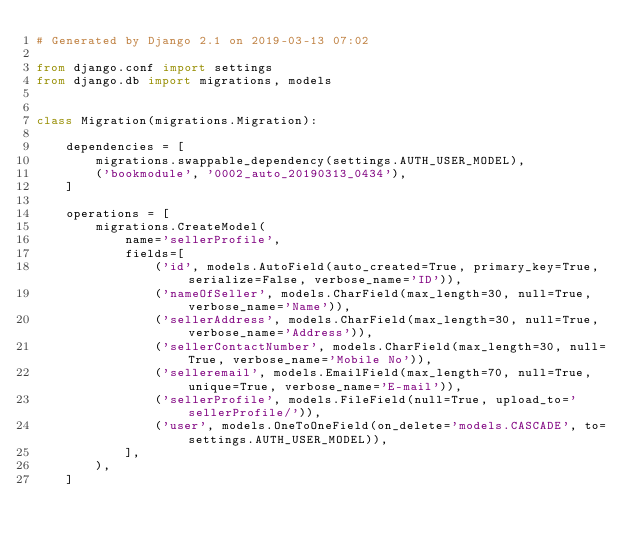<code> <loc_0><loc_0><loc_500><loc_500><_Python_># Generated by Django 2.1 on 2019-03-13 07:02

from django.conf import settings
from django.db import migrations, models


class Migration(migrations.Migration):

    dependencies = [
        migrations.swappable_dependency(settings.AUTH_USER_MODEL),
        ('bookmodule', '0002_auto_20190313_0434'),
    ]

    operations = [
        migrations.CreateModel(
            name='sellerProfile',
            fields=[
                ('id', models.AutoField(auto_created=True, primary_key=True, serialize=False, verbose_name='ID')),
                ('nameOfSeller', models.CharField(max_length=30, null=True, verbose_name='Name')),
                ('sellerAddress', models.CharField(max_length=30, null=True, verbose_name='Address')),
                ('sellerContactNumber', models.CharField(max_length=30, null=True, verbose_name='Mobile No')),
                ('selleremail', models.EmailField(max_length=70, null=True, unique=True, verbose_name='E-mail')),
                ('sellerProfile', models.FileField(null=True, upload_to='sellerProfile/')),
                ('user', models.OneToOneField(on_delete='models.CASCADE', to=settings.AUTH_USER_MODEL)),
            ],
        ),
    ]
</code> 